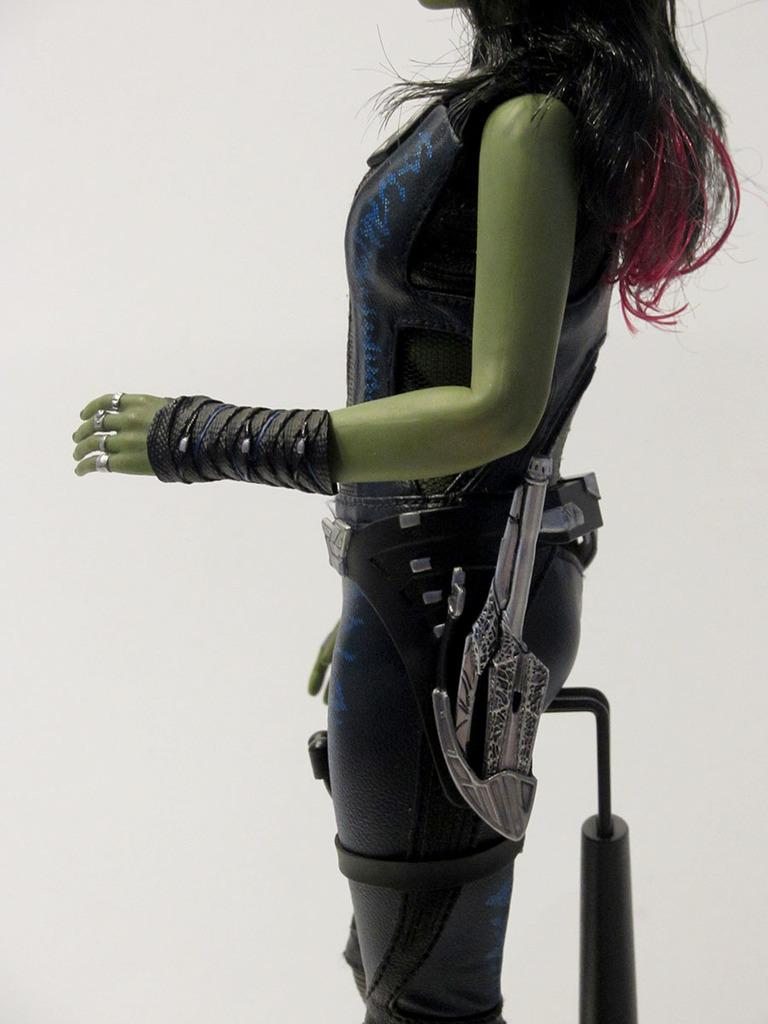What type of object is depicted in the image? There is a toy of a woman in the image. Can you describe the toy in more detail? The toy is likely a figurine or doll, representing a woman. What type of competition is the woman participating in within the image? There is no competition present in the image; it only features a toy of a woman. 